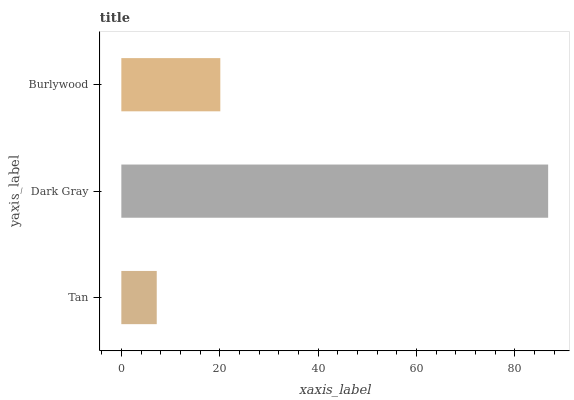Is Tan the minimum?
Answer yes or no. Yes. Is Dark Gray the maximum?
Answer yes or no. Yes. Is Burlywood the minimum?
Answer yes or no. No. Is Burlywood the maximum?
Answer yes or no. No. Is Dark Gray greater than Burlywood?
Answer yes or no. Yes. Is Burlywood less than Dark Gray?
Answer yes or no. Yes. Is Burlywood greater than Dark Gray?
Answer yes or no. No. Is Dark Gray less than Burlywood?
Answer yes or no. No. Is Burlywood the high median?
Answer yes or no. Yes. Is Burlywood the low median?
Answer yes or no. Yes. Is Tan the high median?
Answer yes or no. No. Is Tan the low median?
Answer yes or no. No. 